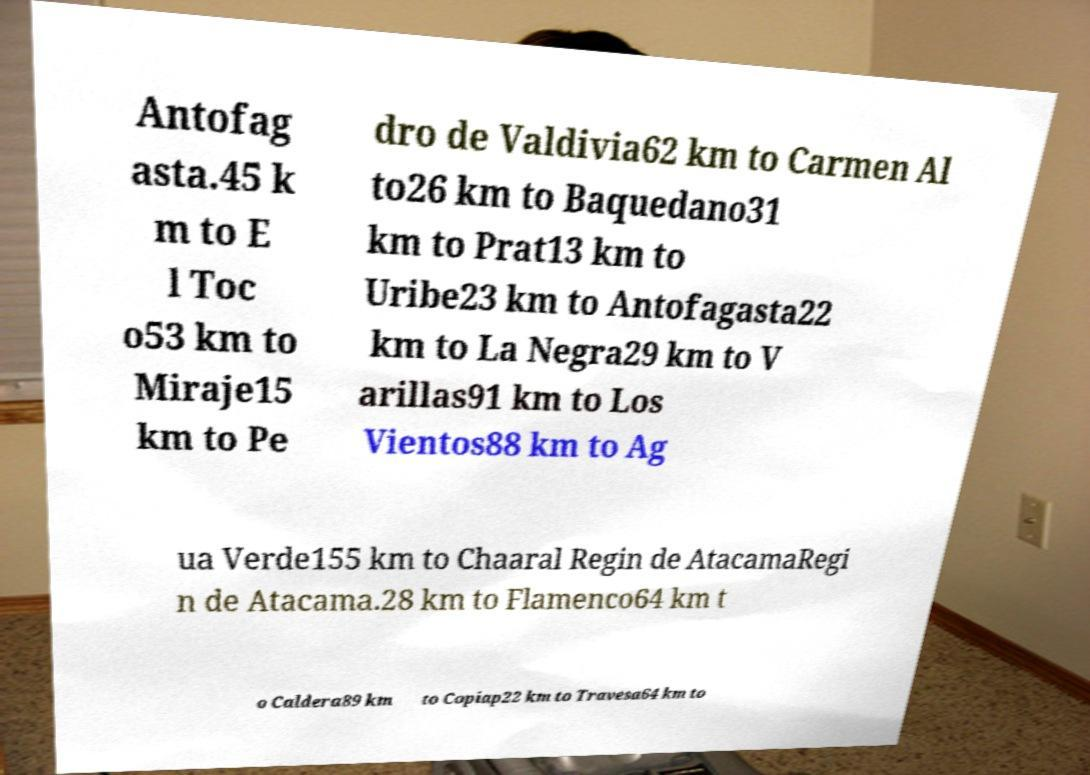Can you accurately transcribe the text from the provided image for me? Antofag asta.45 k m to E l Toc o53 km to Miraje15 km to Pe dro de Valdivia62 km to Carmen Al to26 km to Baquedano31 km to Prat13 km to Uribe23 km to Antofagasta22 km to La Negra29 km to V arillas91 km to Los Vientos88 km to Ag ua Verde155 km to Chaaral Regin de AtacamaRegi n de Atacama.28 km to Flamenco64 km t o Caldera89 km to Copiap22 km to Travesa64 km to 